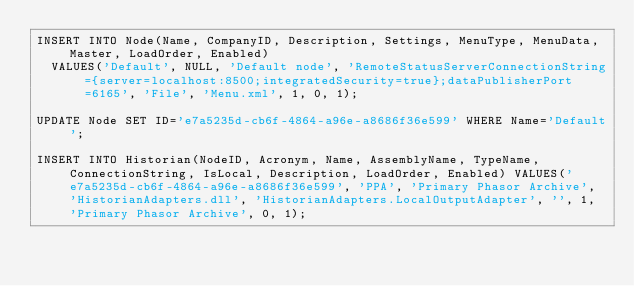Convert code to text. <code><loc_0><loc_0><loc_500><loc_500><_SQL_>INSERT INTO Node(Name, CompanyID, Description, Settings, MenuType, MenuData, Master, LoadOrder, Enabled) 
	VALUES('Default', NULL, 'Default node', 'RemoteStatusServerConnectionString={server=localhost:8500;integratedSecurity=true};dataPublisherPort=6165', 'File', 'Menu.xml', 1, 0, 1);

UPDATE Node SET ID='e7a5235d-cb6f-4864-a96e-a8686f36e599' WHERE Name='Default';

INSERT INTO Historian(NodeID, Acronym, Name, AssemblyName, TypeName, ConnectionString, IsLocal, Description, LoadOrder, Enabled) VALUES('e7a5235d-cb6f-4864-a96e-a8686f36e599', 'PPA', 'Primary Phasor Archive', 'HistorianAdapters.dll', 'HistorianAdapters.LocalOutputAdapter', '', 1, 'Primary Phasor Archive', 0, 1);</code> 